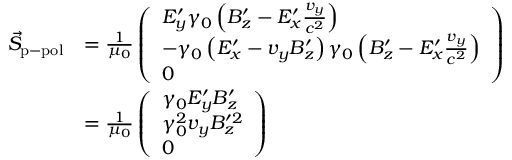Convert formula to latex. <formula><loc_0><loc_0><loc_500><loc_500>\begin{array} { r l } { \vec { S } _ { p - p o l } } & { = \frac { 1 } { \mu _ { 0 } } \left ( \begin{array} { l } { E _ { y } ^ { \prime } \gamma _ { 0 } \left ( B _ { z } ^ { \prime } - E _ { x } ^ { \prime } \frac { v _ { y } } { c ^ { 2 } } \right ) } \\ { - \gamma _ { 0 } \left ( E _ { x } ^ { \prime } - v _ { y } B _ { z } ^ { \prime } \right ) \gamma _ { 0 } \left ( B _ { z } ^ { \prime } - E _ { x } ^ { \prime } \frac { v _ { y } } { c ^ { 2 } } \right ) } \\ { 0 } \end{array} \right ) } \\ & { = \frac { 1 } { \mu _ { 0 } } \left ( \begin{array} { l } { \gamma _ { 0 } E _ { y } ^ { \prime } B _ { z } ^ { \prime } } \\ { \gamma _ { 0 } ^ { 2 } v _ { y } B _ { z } ^ { \prime 2 } } \\ { 0 } \end{array} \right ) } \end{array}</formula> 